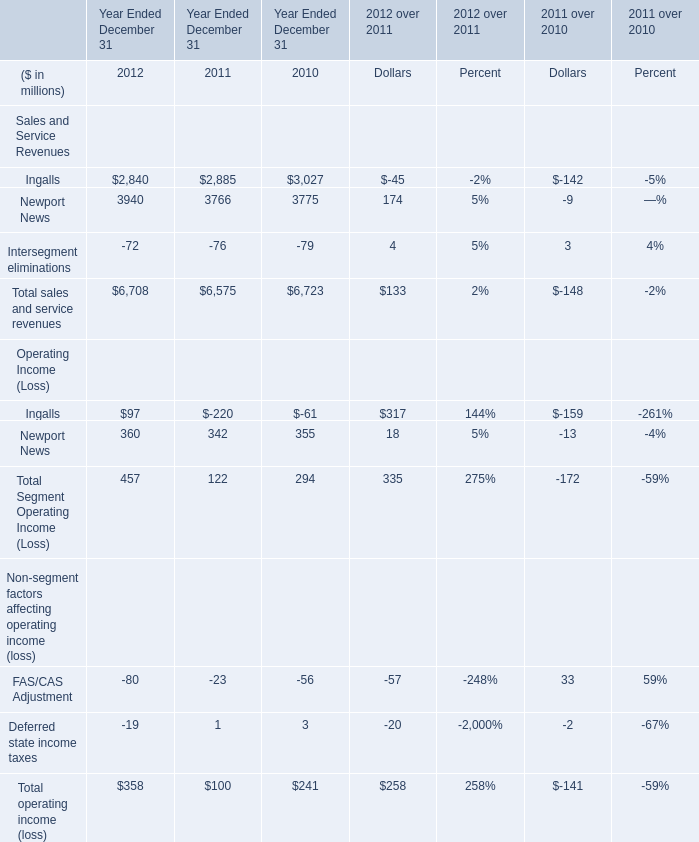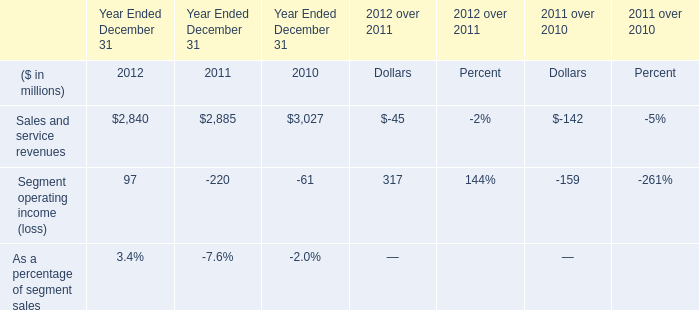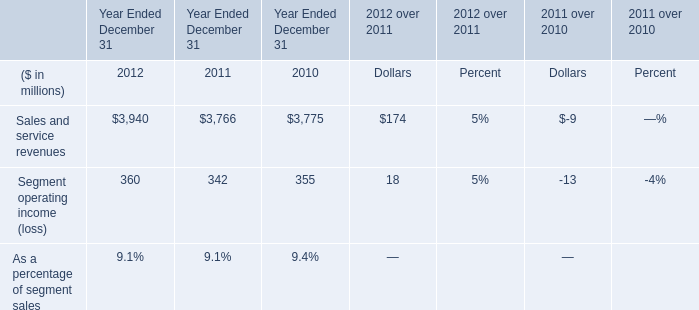What will Total sales and service revenues be like in 2013 if it develops with the same increasing rate as current? (in million) 
Computations: ((((6708 - 6575) / 6575) + 1) * 6708)
Answer: 6843.69034. 